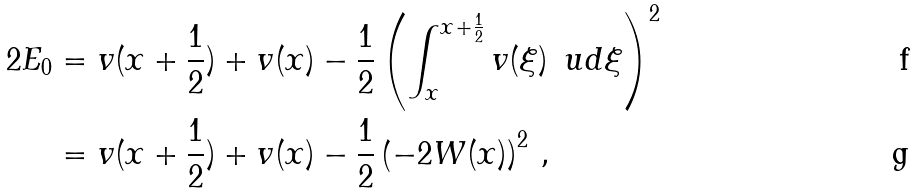<formula> <loc_0><loc_0><loc_500><loc_500>2 E _ { 0 } & = v ( x + \frac { 1 } { 2 } ) + v ( x ) - \frac { 1 } { 2 } \left ( \int _ { x } ^ { x + \frac { 1 } { 2 } } v ( \xi ) \, \ u d \xi \right ) ^ { 2 } \\ & = v ( x + \frac { 1 } { 2 } ) + v ( x ) - \frac { 1 } { 2 } \left ( - 2 W ( x ) \right ) ^ { 2 } \, ,</formula> 